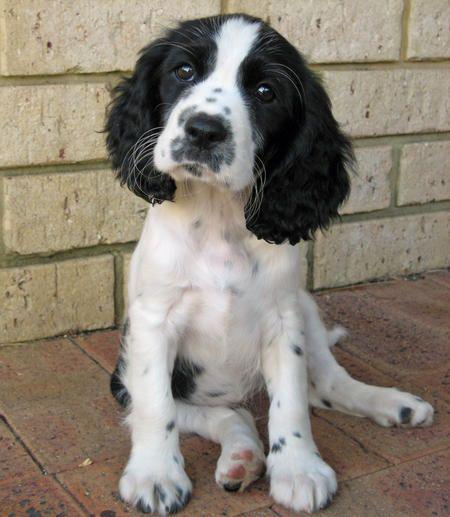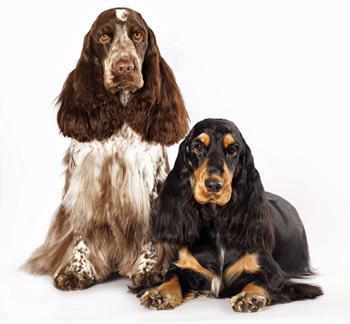The first image is the image on the left, the second image is the image on the right. Assess this claim about the two images: "Two out of the three dogs have some black fur.". Correct or not? Answer yes or no. Yes. The first image is the image on the left, the second image is the image on the right. Evaluate the accuracy of this statement regarding the images: "One image shows a spaniel with a white muzzle and black fur on eye and ear areas, and the other image shows two different colored spaniels posed close together.". Is it true? Answer yes or no. Yes. 